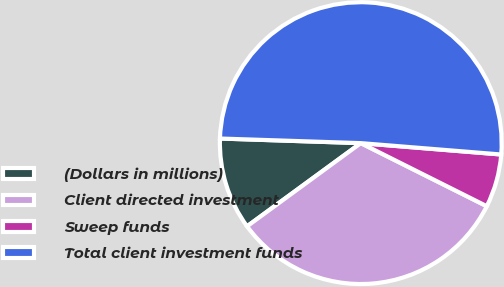Convert chart. <chart><loc_0><loc_0><loc_500><loc_500><pie_chart><fcel>(Dollars in millions)<fcel>Client directed investment<fcel>Sweep funds<fcel>Total client investment funds<nl><fcel>10.57%<fcel>32.56%<fcel>6.1%<fcel>50.76%<nl></chart> 